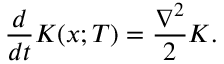Convert formula to latex. <formula><loc_0><loc_0><loc_500><loc_500>{ \frac { d } { d t } } K ( x ; T ) = { \frac { \nabla ^ { 2 } } { 2 } } K .</formula> 